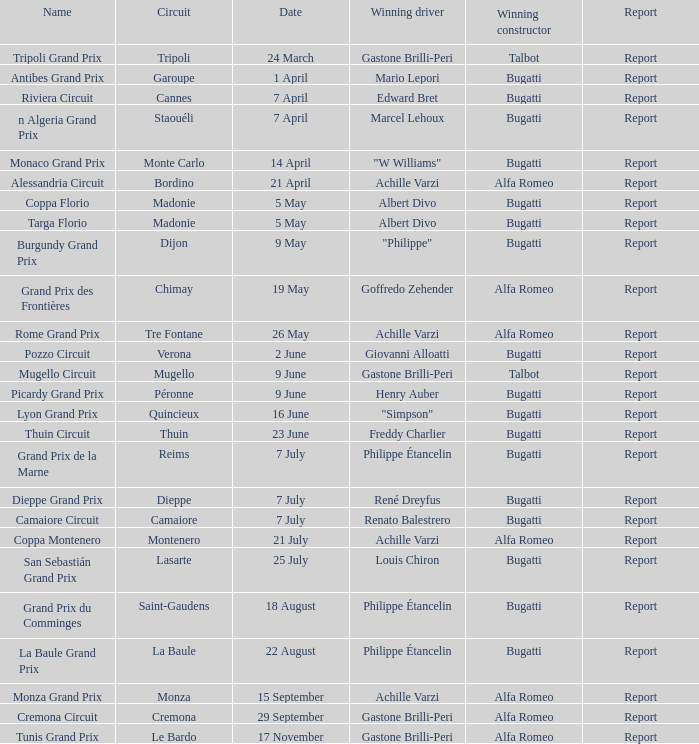What Circuit has a Winning constructor of bugatti, and a Winning driver of edward bret? Cannes. 